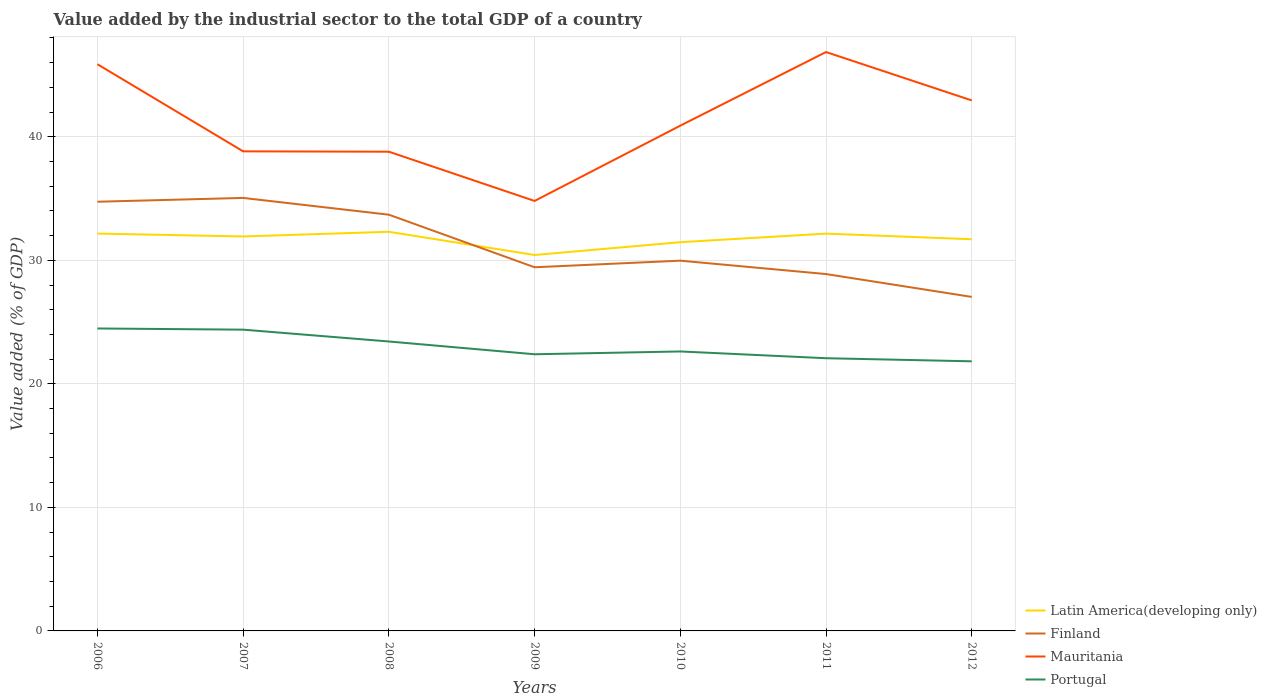Does the line corresponding to Mauritania intersect with the line corresponding to Portugal?
Keep it short and to the point. No. Is the number of lines equal to the number of legend labels?
Keep it short and to the point. Yes. Across all years, what is the maximum value added by the industrial sector to the total GDP in Latin America(developing only)?
Provide a succinct answer. 30.43. In which year was the value added by the industrial sector to the total GDP in Portugal maximum?
Keep it short and to the point. 2012. What is the total value added by the industrial sector to the total GDP in Mauritania in the graph?
Your answer should be compact. -2.04. What is the difference between the highest and the second highest value added by the industrial sector to the total GDP in Latin America(developing only)?
Offer a terse response. 1.88. How many years are there in the graph?
Ensure brevity in your answer.  7. What is the difference between two consecutive major ticks on the Y-axis?
Provide a short and direct response. 10. Are the values on the major ticks of Y-axis written in scientific E-notation?
Offer a very short reply. No. Does the graph contain grids?
Make the answer very short. Yes. How are the legend labels stacked?
Provide a succinct answer. Vertical. What is the title of the graph?
Ensure brevity in your answer.  Value added by the industrial sector to the total GDP of a country. Does "Pacific island small states" appear as one of the legend labels in the graph?
Provide a succinct answer. No. What is the label or title of the X-axis?
Make the answer very short. Years. What is the label or title of the Y-axis?
Offer a terse response. Value added (% of GDP). What is the Value added (% of GDP) in Latin America(developing only) in 2006?
Give a very brief answer. 32.17. What is the Value added (% of GDP) of Finland in 2006?
Keep it short and to the point. 34.74. What is the Value added (% of GDP) in Mauritania in 2006?
Your answer should be compact. 45.88. What is the Value added (% of GDP) of Portugal in 2006?
Keep it short and to the point. 24.49. What is the Value added (% of GDP) of Latin America(developing only) in 2007?
Offer a very short reply. 31.93. What is the Value added (% of GDP) in Finland in 2007?
Your response must be concise. 35.05. What is the Value added (% of GDP) of Mauritania in 2007?
Provide a succinct answer. 38.82. What is the Value added (% of GDP) in Portugal in 2007?
Your answer should be compact. 24.39. What is the Value added (% of GDP) of Latin America(developing only) in 2008?
Ensure brevity in your answer.  32.31. What is the Value added (% of GDP) of Finland in 2008?
Offer a terse response. 33.7. What is the Value added (% of GDP) of Mauritania in 2008?
Give a very brief answer. 38.8. What is the Value added (% of GDP) in Portugal in 2008?
Give a very brief answer. 23.43. What is the Value added (% of GDP) in Latin America(developing only) in 2009?
Your answer should be very brief. 30.43. What is the Value added (% of GDP) in Finland in 2009?
Provide a short and direct response. 29.44. What is the Value added (% of GDP) of Mauritania in 2009?
Your answer should be compact. 34.81. What is the Value added (% of GDP) in Portugal in 2009?
Make the answer very short. 22.4. What is the Value added (% of GDP) of Latin America(developing only) in 2010?
Your answer should be very brief. 31.47. What is the Value added (% of GDP) in Finland in 2010?
Give a very brief answer. 29.97. What is the Value added (% of GDP) of Mauritania in 2010?
Your response must be concise. 40.9. What is the Value added (% of GDP) in Portugal in 2010?
Provide a succinct answer. 22.62. What is the Value added (% of GDP) of Latin America(developing only) in 2011?
Provide a succinct answer. 32.16. What is the Value added (% of GDP) of Finland in 2011?
Make the answer very short. 28.89. What is the Value added (% of GDP) of Mauritania in 2011?
Provide a short and direct response. 46.86. What is the Value added (% of GDP) in Portugal in 2011?
Ensure brevity in your answer.  22.08. What is the Value added (% of GDP) of Latin America(developing only) in 2012?
Provide a succinct answer. 31.71. What is the Value added (% of GDP) of Finland in 2012?
Make the answer very short. 27.04. What is the Value added (% of GDP) in Mauritania in 2012?
Keep it short and to the point. 42.95. What is the Value added (% of GDP) of Portugal in 2012?
Your response must be concise. 21.83. Across all years, what is the maximum Value added (% of GDP) in Latin America(developing only)?
Your response must be concise. 32.31. Across all years, what is the maximum Value added (% of GDP) of Finland?
Provide a short and direct response. 35.05. Across all years, what is the maximum Value added (% of GDP) in Mauritania?
Make the answer very short. 46.86. Across all years, what is the maximum Value added (% of GDP) in Portugal?
Offer a very short reply. 24.49. Across all years, what is the minimum Value added (% of GDP) of Latin America(developing only)?
Keep it short and to the point. 30.43. Across all years, what is the minimum Value added (% of GDP) in Finland?
Your answer should be compact. 27.04. Across all years, what is the minimum Value added (% of GDP) of Mauritania?
Ensure brevity in your answer.  34.81. Across all years, what is the minimum Value added (% of GDP) in Portugal?
Give a very brief answer. 21.83. What is the total Value added (% of GDP) of Latin America(developing only) in the graph?
Ensure brevity in your answer.  222.19. What is the total Value added (% of GDP) in Finland in the graph?
Provide a succinct answer. 218.84. What is the total Value added (% of GDP) of Mauritania in the graph?
Provide a short and direct response. 289.02. What is the total Value added (% of GDP) in Portugal in the graph?
Offer a very short reply. 161.23. What is the difference between the Value added (% of GDP) in Latin America(developing only) in 2006 and that in 2007?
Your answer should be compact. 0.23. What is the difference between the Value added (% of GDP) in Finland in 2006 and that in 2007?
Offer a terse response. -0.31. What is the difference between the Value added (% of GDP) of Mauritania in 2006 and that in 2007?
Offer a terse response. 7.05. What is the difference between the Value added (% of GDP) in Portugal in 2006 and that in 2007?
Make the answer very short. 0.1. What is the difference between the Value added (% of GDP) in Latin America(developing only) in 2006 and that in 2008?
Keep it short and to the point. -0.14. What is the difference between the Value added (% of GDP) in Finland in 2006 and that in 2008?
Offer a very short reply. 1.05. What is the difference between the Value added (% of GDP) in Mauritania in 2006 and that in 2008?
Offer a terse response. 7.08. What is the difference between the Value added (% of GDP) of Portugal in 2006 and that in 2008?
Provide a short and direct response. 1.05. What is the difference between the Value added (% of GDP) of Latin America(developing only) in 2006 and that in 2009?
Offer a terse response. 1.74. What is the difference between the Value added (% of GDP) in Finland in 2006 and that in 2009?
Provide a short and direct response. 5.31. What is the difference between the Value added (% of GDP) in Mauritania in 2006 and that in 2009?
Offer a terse response. 11.07. What is the difference between the Value added (% of GDP) of Portugal in 2006 and that in 2009?
Your response must be concise. 2.09. What is the difference between the Value added (% of GDP) of Latin America(developing only) in 2006 and that in 2010?
Give a very brief answer. 0.7. What is the difference between the Value added (% of GDP) of Finland in 2006 and that in 2010?
Provide a short and direct response. 4.77. What is the difference between the Value added (% of GDP) in Mauritania in 2006 and that in 2010?
Ensure brevity in your answer.  4.97. What is the difference between the Value added (% of GDP) of Portugal in 2006 and that in 2010?
Offer a terse response. 1.86. What is the difference between the Value added (% of GDP) of Latin America(developing only) in 2006 and that in 2011?
Your answer should be very brief. 0.01. What is the difference between the Value added (% of GDP) in Finland in 2006 and that in 2011?
Your answer should be very brief. 5.85. What is the difference between the Value added (% of GDP) in Mauritania in 2006 and that in 2011?
Offer a very short reply. -0.99. What is the difference between the Value added (% of GDP) in Portugal in 2006 and that in 2011?
Keep it short and to the point. 2.41. What is the difference between the Value added (% of GDP) of Latin America(developing only) in 2006 and that in 2012?
Your answer should be very brief. 0.46. What is the difference between the Value added (% of GDP) in Finland in 2006 and that in 2012?
Offer a very short reply. 7.7. What is the difference between the Value added (% of GDP) of Mauritania in 2006 and that in 2012?
Ensure brevity in your answer.  2.93. What is the difference between the Value added (% of GDP) in Portugal in 2006 and that in 2012?
Your answer should be compact. 2.66. What is the difference between the Value added (% of GDP) in Latin America(developing only) in 2007 and that in 2008?
Your answer should be very brief. -0.38. What is the difference between the Value added (% of GDP) in Finland in 2007 and that in 2008?
Offer a very short reply. 1.36. What is the difference between the Value added (% of GDP) in Mauritania in 2007 and that in 2008?
Keep it short and to the point. 0.03. What is the difference between the Value added (% of GDP) of Portugal in 2007 and that in 2008?
Offer a very short reply. 0.96. What is the difference between the Value added (% of GDP) in Latin America(developing only) in 2007 and that in 2009?
Your answer should be compact. 1.5. What is the difference between the Value added (% of GDP) of Finland in 2007 and that in 2009?
Your answer should be very brief. 5.61. What is the difference between the Value added (% of GDP) of Mauritania in 2007 and that in 2009?
Ensure brevity in your answer.  4.02. What is the difference between the Value added (% of GDP) in Portugal in 2007 and that in 2009?
Your answer should be very brief. 1.99. What is the difference between the Value added (% of GDP) of Latin America(developing only) in 2007 and that in 2010?
Make the answer very short. 0.46. What is the difference between the Value added (% of GDP) in Finland in 2007 and that in 2010?
Make the answer very short. 5.08. What is the difference between the Value added (% of GDP) in Mauritania in 2007 and that in 2010?
Give a very brief answer. -2.08. What is the difference between the Value added (% of GDP) of Portugal in 2007 and that in 2010?
Keep it short and to the point. 1.76. What is the difference between the Value added (% of GDP) of Latin America(developing only) in 2007 and that in 2011?
Ensure brevity in your answer.  -0.23. What is the difference between the Value added (% of GDP) in Finland in 2007 and that in 2011?
Your response must be concise. 6.16. What is the difference between the Value added (% of GDP) of Mauritania in 2007 and that in 2011?
Make the answer very short. -8.04. What is the difference between the Value added (% of GDP) in Portugal in 2007 and that in 2011?
Your response must be concise. 2.31. What is the difference between the Value added (% of GDP) of Latin America(developing only) in 2007 and that in 2012?
Your response must be concise. 0.23. What is the difference between the Value added (% of GDP) in Finland in 2007 and that in 2012?
Provide a short and direct response. 8.01. What is the difference between the Value added (% of GDP) in Mauritania in 2007 and that in 2012?
Offer a very short reply. -4.12. What is the difference between the Value added (% of GDP) in Portugal in 2007 and that in 2012?
Ensure brevity in your answer.  2.56. What is the difference between the Value added (% of GDP) of Latin America(developing only) in 2008 and that in 2009?
Your answer should be very brief. 1.88. What is the difference between the Value added (% of GDP) of Finland in 2008 and that in 2009?
Provide a succinct answer. 4.26. What is the difference between the Value added (% of GDP) in Mauritania in 2008 and that in 2009?
Provide a succinct answer. 3.99. What is the difference between the Value added (% of GDP) of Portugal in 2008 and that in 2009?
Provide a short and direct response. 1.03. What is the difference between the Value added (% of GDP) in Latin America(developing only) in 2008 and that in 2010?
Your response must be concise. 0.84. What is the difference between the Value added (% of GDP) in Finland in 2008 and that in 2010?
Offer a terse response. 3.72. What is the difference between the Value added (% of GDP) of Mauritania in 2008 and that in 2010?
Provide a short and direct response. -2.11. What is the difference between the Value added (% of GDP) of Portugal in 2008 and that in 2010?
Make the answer very short. 0.81. What is the difference between the Value added (% of GDP) in Latin America(developing only) in 2008 and that in 2011?
Ensure brevity in your answer.  0.15. What is the difference between the Value added (% of GDP) of Finland in 2008 and that in 2011?
Provide a succinct answer. 4.81. What is the difference between the Value added (% of GDP) in Mauritania in 2008 and that in 2011?
Your answer should be very brief. -8.07. What is the difference between the Value added (% of GDP) in Portugal in 2008 and that in 2011?
Your answer should be very brief. 1.35. What is the difference between the Value added (% of GDP) in Latin America(developing only) in 2008 and that in 2012?
Your response must be concise. 0.61. What is the difference between the Value added (% of GDP) of Finland in 2008 and that in 2012?
Ensure brevity in your answer.  6.66. What is the difference between the Value added (% of GDP) in Mauritania in 2008 and that in 2012?
Provide a succinct answer. -4.15. What is the difference between the Value added (% of GDP) of Portugal in 2008 and that in 2012?
Your answer should be compact. 1.61. What is the difference between the Value added (% of GDP) in Latin America(developing only) in 2009 and that in 2010?
Give a very brief answer. -1.04. What is the difference between the Value added (% of GDP) of Finland in 2009 and that in 2010?
Give a very brief answer. -0.53. What is the difference between the Value added (% of GDP) of Mauritania in 2009 and that in 2010?
Offer a very short reply. -6.1. What is the difference between the Value added (% of GDP) in Portugal in 2009 and that in 2010?
Ensure brevity in your answer.  -0.23. What is the difference between the Value added (% of GDP) of Latin America(developing only) in 2009 and that in 2011?
Your answer should be compact. -1.73. What is the difference between the Value added (% of GDP) of Finland in 2009 and that in 2011?
Provide a succinct answer. 0.55. What is the difference between the Value added (% of GDP) in Mauritania in 2009 and that in 2011?
Your answer should be very brief. -12.05. What is the difference between the Value added (% of GDP) of Portugal in 2009 and that in 2011?
Provide a short and direct response. 0.32. What is the difference between the Value added (% of GDP) in Latin America(developing only) in 2009 and that in 2012?
Offer a terse response. -1.27. What is the difference between the Value added (% of GDP) of Finland in 2009 and that in 2012?
Offer a terse response. 2.4. What is the difference between the Value added (% of GDP) of Mauritania in 2009 and that in 2012?
Give a very brief answer. -8.14. What is the difference between the Value added (% of GDP) in Portugal in 2009 and that in 2012?
Provide a succinct answer. 0.57. What is the difference between the Value added (% of GDP) of Latin America(developing only) in 2010 and that in 2011?
Your response must be concise. -0.69. What is the difference between the Value added (% of GDP) in Finland in 2010 and that in 2011?
Make the answer very short. 1.08. What is the difference between the Value added (% of GDP) in Mauritania in 2010 and that in 2011?
Provide a succinct answer. -5.96. What is the difference between the Value added (% of GDP) of Portugal in 2010 and that in 2011?
Your answer should be very brief. 0.55. What is the difference between the Value added (% of GDP) in Latin America(developing only) in 2010 and that in 2012?
Provide a short and direct response. -0.24. What is the difference between the Value added (% of GDP) in Finland in 2010 and that in 2012?
Make the answer very short. 2.93. What is the difference between the Value added (% of GDP) of Mauritania in 2010 and that in 2012?
Give a very brief answer. -2.04. What is the difference between the Value added (% of GDP) in Portugal in 2010 and that in 2012?
Your answer should be very brief. 0.8. What is the difference between the Value added (% of GDP) of Latin America(developing only) in 2011 and that in 2012?
Provide a short and direct response. 0.46. What is the difference between the Value added (% of GDP) of Finland in 2011 and that in 2012?
Ensure brevity in your answer.  1.85. What is the difference between the Value added (% of GDP) in Mauritania in 2011 and that in 2012?
Keep it short and to the point. 3.92. What is the difference between the Value added (% of GDP) in Portugal in 2011 and that in 2012?
Provide a succinct answer. 0.25. What is the difference between the Value added (% of GDP) of Latin America(developing only) in 2006 and the Value added (% of GDP) of Finland in 2007?
Give a very brief answer. -2.89. What is the difference between the Value added (% of GDP) in Latin America(developing only) in 2006 and the Value added (% of GDP) in Mauritania in 2007?
Offer a very short reply. -6.66. What is the difference between the Value added (% of GDP) in Latin America(developing only) in 2006 and the Value added (% of GDP) in Portugal in 2007?
Give a very brief answer. 7.78. What is the difference between the Value added (% of GDP) in Finland in 2006 and the Value added (% of GDP) in Mauritania in 2007?
Your response must be concise. -4.08. What is the difference between the Value added (% of GDP) in Finland in 2006 and the Value added (% of GDP) in Portugal in 2007?
Make the answer very short. 10.36. What is the difference between the Value added (% of GDP) of Mauritania in 2006 and the Value added (% of GDP) of Portugal in 2007?
Make the answer very short. 21.49. What is the difference between the Value added (% of GDP) of Latin America(developing only) in 2006 and the Value added (% of GDP) of Finland in 2008?
Provide a short and direct response. -1.53. What is the difference between the Value added (% of GDP) in Latin America(developing only) in 2006 and the Value added (% of GDP) in Mauritania in 2008?
Keep it short and to the point. -6.63. What is the difference between the Value added (% of GDP) in Latin America(developing only) in 2006 and the Value added (% of GDP) in Portugal in 2008?
Make the answer very short. 8.74. What is the difference between the Value added (% of GDP) of Finland in 2006 and the Value added (% of GDP) of Mauritania in 2008?
Your answer should be compact. -4.05. What is the difference between the Value added (% of GDP) in Finland in 2006 and the Value added (% of GDP) in Portugal in 2008?
Ensure brevity in your answer.  11.31. What is the difference between the Value added (% of GDP) of Mauritania in 2006 and the Value added (% of GDP) of Portugal in 2008?
Your answer should be compact. 22.45. What is the difference between the Value added (% of GDP) of Latin America(developing only) in 2006 and the Value added (% of GDP) of Finland in 2009?
Give a very brief answer. 2.73. What is the difference between the Value added (% of GDP) of Latin America(developing only) in 2006 and the Value added (% of GDP) of Mauritania in 2009?
Your response must be concise. -2.64. What is the difference between the Value added (% of GDP) of Latin America(developing only) in 2006 and the Value added (% of GDP) of Portugal in 2009?
Provide a short and direct response. 9.77. What is the difference between the Value added (% of GDP) of Finland in 2006 and the Value added (% of GDP) of Mauritania in 2009?
Provide a short and direct response. -0.06. What is the difference between the Value added (% of GDP) of Finland in 2006 and the Value added (% of GDP) of Portugal in 2009?
Your answer should be very brief. 12.35. What is the difference between the Value added (% of GDP) in Mauritania in 2006 and the Value added (% of GDP) in Portugal in 2009?
Keep it short and to the point. 23.48. What is the difference between the Value added (% of GDP) of Latin America(developing only) in 2006 and the Value added (% of GDP) of Finland in 2010?
Your response must be concise. 2.19. What is the difference between the Value added (% of GDP) of Latin America(developing only) in 2006 and the Value added (% of GDP) of Mauritania in 2010?
Keep it short and to the point. -8.74. What is the difference between the Value added (% of GDP) of Latin America(developing only) in 2006 and the Value added (% of GDP) of Portugal in 2010?
Offer a terse response. 9.54. What is the difference between the Value added (% of GDP) in Finland in 2006 and the Value added (% of GDP) in Mauritania in 2010?
Offer a very short reply. -6.16. What is the difference between the Value added (% of GDP) in Finland in 2006 and the Value added (% of GDP) in Portugal in 2010?
Ensure brevity in your answer.  12.12. What is the difference between the Value added (% of GDP) of Mauritania in 2006 and the Value added (% of GDP) of Portugal in 2010?
Your answer should be compact. 23.25. What is the difference between the Value added (% of GDP) of Latin America(developing only) in 2006 and the Value added (% of GDP) of Finland in 2011?
Your answer should be compact. 3.28. What is the difference between the Value added (% of GDP) in Latin America(developing only) in 2006 and the Value added (% of GDP) in Mauritania in 2011?
Your answer should be very brief. -14.7. What is the difference between the Value added (% of GDP) in Latin America(developing only) in 2006 and the Value added (% of GDP) in Portugal in 2011?
Make the answer very short. 10.09. What is the difference between the Value added (% of GDP) in Finland in 2006 and the Value added (% of GDP) in Mauritania in 2011?
Give a very brief answer. -12.12. What is the difference between the Value added (% of GDP) of Finland in 2006 and the Value added (% of GDP) of Portugal in 2011?
Keep it short and to the point. 12.67. What is the difference between the Value added (% of GDP) of Mauritania in 2006 and the Value added (% of GDP) of Portugal in 2011?
Ensure brevity in your answer.  23.8. What is the difference between the Value added (% of GDP) of Latin America(developing only) in 2006 and the Value added (% of GDP) of Finland in 2012?
Provide a succinct answer. 5.13. What is the difference between the Value added (% of GDP) in Latin America(developing only) in 2006 and the Value added (% of GDP) in Mauritania in 2012?
Provide a succinct answer. -10.78. What is the difference between the Value added (% of GDP) of Latin America(developing only) in 2006 and the Value added (% of GDP) of Portugal in 2012?
Offer a very short reply. 10.34. What is the difference between the Value added (% of GDP) of Finland in 2006 and the Value added (% of GDP) of Mauritania in 2012?
Provide a short and direct response. -8.2. What is the difference between the Value added (% of GDP) of Finland in 2006 and the Value added (% of GDP) of Portugal in 2012?
Make the answer very short. 12.92. What is the difference between the Value added (% of GDP) in Mauritania in 2006 and the Value added (% of GDP) in Portugal in 2012?
Offer a terse response. 24.05. What is the difference between the Value added (% of GDP) of Latin America(developing only) in 2007 and the Value added (% of GDP) of Finland in 2008?
Make the answer very short. -1.76. What is the difference between the Value added (% of GDP) in Latin America(developing only) in 2007 and the Value added (% of GDP) in Mauritania in 2008?
Your answer should be very brief. -6.86. What is the difference between the Value added (% of GDP) of Latin America(developing only) in 2007 and the Value added (% of GDP) of Portugal in 2008?
Give a very brief answer. 8.5. What is the difference between the Value added (% of GDP) in Finland in 2007 and the Value added (% of GDP) in Mauritania in 2008?
Your response must be concise. -3.74. What is the difference between the Value added (% of GDP) in Finland in 2007 and the Value added (% of GDP) in Portugal in 2008?
Make the answer very short. 11.62. What is the difference between the Value added (% of GDP) of Mauritania in 2007 and the Value added (% of GDP) of Portugal in 2008?
Your response must be concise. 15.39. What is the difference between the Value added (% of GDP) of Latin America(developing only) in 2007 and the Value added (% of GDP) of Finland in 2009?
Provide a succinct answer. 2.49. What is the difference between the Value added (% of GDP) in Latin America(developing only) in 2007 and the Value added (% of GDP) in Mauritania in 2009?
Your response must be concise. -2.87. What is the difference between the Value added (% of GDP) of Latin America(developing only) in 2007 and the Value added (% of GDP) of Portugal in 2009?
Offer a very short reply. 9.54. What is the difference between the Value added (% of GDP) of Finland in 2007 and the Value added (% of GDP) of Mauritania in 2009?
Give a very brief answer. 0.24. What is the difference between the Value added (% of GDP) in Finland in 2007 and the Value added (% of GDP) in Portugal in 2009?
Make the answer very short. 12.66. What is the difference between the Value added (% of GDP) in Mauritania in 2007 and the Value added (% of GDP) in Portugal in 2009?
Your answer should be compact. 16.43. What is the difference between the Value added (% of GDP) in Latin America(developing only) in 2007 and the Value added (% of GDP) in Finland in 2010?
Provide a succinct answer. 1.96. What is the difference between the Value added (% of GDP) in Latin America(developing only) in 2007 and the Value added (% of GDP) in Mauritania in 2010?
Your response must be concise. -8.97. What is the difference between the Value added (% of GDP) in Latin America(developing only) in 2007 and the Value added (% of GDP) in Portugal in 2010?
Ensure brevity in your answer.  9.31. What is the difference between the Value added (% of GDP) of Finland in 2007 and the Value added (% of GDP) of Mauritania in 2010?
Offer a terse response. -5.85. What is the difference between the Value added (% of GDP) of Finland in 2007 and the Value added (% of GDP) of Portugal in 2010?
Provide a short and direct response. 12.43. What is the difference between the Value added (% of GDP) of Mauritania in 2007 and the Value added (% of GDP) of Portugal in 2010?
Provide a succinct answer. 16.2. What is the difference between the Value added (% of GDP) of Latin America(developing only) in 2007 and the Value added (% of GDP) of Finland in 2011?
Make the answer very short. 3.04. What is the difference between the Value added (% of GDP) of Latin America(developing only) in 2007 and the Value added (% of GDP) of Mauritania in 2011?
Ensure brevity in your answer.  -14.93. What is the difference between the Value added (% of GDP) in Latin America(developing only) in 2007 and the Value added (% of GDP) in Portugal in 2011?
Keep it short and to the point. 9.86. What is the difference between the Value added (% of GDP) of Finland in 2007 and the Value added (% of GDP) of Mauritania in 2011?
Give a very brief answer. -11.81. What is the difference between the Value added (% of GDP) in Finland in 2007 and the Value added (% of GDP) in Portugal in 2011?
Offer a terse response. 12.98. What is the difference between the Value added (% of GDP) in Mauritania in 2007 and the Value added (% of GDP) in Portugal in 2011?
Your answer should be very brief. 16.75. What is the difference between the Value added (% of GDP) of Latin America(developing only) in 2007 and the Value added (% of GDP) of Finland in 2012?
Provide a succinct answer. 4.89. What is the difference between the Value added (% of GDP) in Latin America(developing only) in 2007 and the Value added (% of GDP) in Mauritania in 2012?
Offer a very short reply. -11.01. What is the difference between the Value added (% of GDP) in Latin America(developing only) in 2007 and the Value added (% of GDP) in Portugal in 2012?
Keep it short and to the point. 10.11. What is the difference between the Value added (% of GDP) of Finland in 2007 and the Value added (% of GDP) of Mauritania in 2012?
Offer a terse response. -7.89. What is the difference between the Value added (% of GDP) in Finland in 2007 and the Value added (% of GDP) in Portugal in 2012?
Keep it short and to the point. 13.23. What is the difference between the Value added (% of GDP) of Mauritania in 2007 and the Value added (% of GDP) of Portugal in 2012?
Your answer should be compact. 17. What is the difference between the Value added (% of GDP) of Latin America(developing only) in 2008 and the Value added (% of GDP) of Finland in 2009?
Keep it short and to the point. 2.87. What is the difference between the Value added (% of GDP) of Latin America(developing only) in 2008 and the Value added (% of GDP) of Mauritania in 2009?
Offer a terse response. -2.5. What is the difference between the Value added (% of GDP) of Latin America(developing only) in 2008 and the Value added (% of GDP) of Portugal in 2009?
Your answer should be compact. 9.92. What is the difference between the Value added (% of GDP) in Finland in 2008 and the Value added (% of GDP) in Mauritania in 2009?
Give a very brief answer. -1.11. What is the difference between the Value added (% of GDP) of Finland in 2008 and the Value added (% of GDP) of Portugal in 2009?
Your answer should be very brief. 11.3. What is the difference between the Value added (% of GDP) in Mauritania in 2008 and the Value added (% of GDP) in Portugal in 2009?
Your answer should be very brief. 16.4. What is the difference between the Value added (% of GDP) of Latin America(developing only) in 2008 and the Value added (% of GDP) of Finland in 2010?
Your answer should be very brief. 2.34. What is the difference between the Value added (% of GDP) of Latin America(developing only) in 2008 and the Value added (% of GDP) of Mauritania in 2010?
Make the answer very short. -8.59. What is the difference between the Value added (% of GDP) in Latin America(developing only) in 2008 and the Value added (% of GDP) in Portugal in 2010?
Offer a very short reply. 9.69. What is the difference between the Value added (% of GDP) of Finland in 2008 and the Value added (% of GDP) of Mauritania in 2010?
Make the answer very short. -7.21. What is the difference between the Value added (% of GDP) of Finland in 2008 and the Value added (% of GDP) of Portugal in 2010?
Keep it short and to the point. 11.07. What is the difference between the Value added (% of GDP) of Mauritania in 2008 and the Value added (% of GDP) of Portugal in 2010?
Give a very brief answer. 16.17. What is the difference between the Value added (% of GDP) of Latin America(developing only) in 2008 and the Value added (% of GDP) of Finland in 2011?
Provide a succinct answer. 3.42. What is the difference between the Value added (% of GDP) in Latin America(developing only) in 2008 and the Value added (% of GDP) in Mauritania in 2011?
Ensure brevity in your answer.  -14.55. What is the difference between the Value added (% of GDP) in Latin America(developing only) in 2008 and the Value added (% of GDP) in Portugal in 2011?
Offer a terse response. 10.24. What is the difference between the Value added (% of GDP) in Finland in 2008 and the Value added (% of GDP) in Mauritania in 2011?
Provide a succinct answer. -13.17. What is the difference between the Value added (% of GDP) in Finland in 2008 and the Value added (% of GDP) in Portugal in 2011?
Your response must be concise. 11.62. What is the difference between the Value added (% of GDP) in Mauritania in 2008 and the Value added (% of GDP) in Portugal in 2011?
Offer a terse response. 16.72. What is the difference between the Value added (% of GDP) in Latin America(developing only) in 2008 and the Value added (% of GDP) in Finland in 2012?
Your response must be concise. 5.27. What is the difference between the Value added (% of GDP) in Latin America(developing only) in 2008 and the Value added (% of GDP) in Mauritania in 2012?
Keep it short and to the point. -10.64. What is the difference between the Value added (% of GDP) in Latin America(developing only) in 2008 and the Value added (% of GDP) in Portugal in 2012?
Give a very brief answer. 10.49. What is the difference between the Value added (% of GDP) in Finland in 2008 and the Value added (% of GDP) in Mauritania in 2012?
Give a very brief answer. -9.25. What is the difference between the Value added (% of GDP) of Finland in 2008 and the Value added (% of GDP) of Portugal in 2012?
Your response must be concise. 11.87. What is the difference between the Value added (% of GDP) in Mauritania in 2008 and the Value added (% of GDP) in Portugal in 2012?
Make the answer very short. 16.97. What is the difference between the Value added (% of GDP) of Latin America(developing only) in 2009 and the Value added (% of GDP) of Finland in 2010?
Provide a succinct answer. 0.46. What is the difference between the Value added (% of GDP) in Latin America(developing only) in 2009 and the Value added (% of GDP) in Mauritania in 2010?
Your response must be concise. -10.47. What is the difference between the Value added (% of GDP) of Latin America(developing only) in 2009 and the Value added (% of GDP) of Portugal in 2010?
Keep it short and to the point. 7.81. What is the difference between the Value added (% of GDP) in Finland in 2009 and the Value added (% of GDP) in Mauritania in 2010?
Provide a short and direct response. -11.46. What is the difference between the Value added (% of GDP) of Finland in 2009 and the Value added (% of GDP) of Portugal in 2010?
Make the answer very short. 6.82. What is the difference between the Value added (% of GDP) in Mauritania in 2009 and the Value added (% of GDP) in Portugal in 2010?
Keep it short and to the point. 12.18. What is the difference between the Value added (% of GDP) in Latin America(developing only) in 2009 and the Value added (% of GDP) in Finland in 2011?
Offer a very short reply. 1.54. What is the difference between the Value added (% of GDP) of Latin America(developing only) in 2009 and the Value added (% of GDP) of Mauritania in 2011?
Provide a short and direct response. -16.43. What is the difference between the Value added (% of GDP) of Latin America(developing only) in 2009 and the Value added (% of GDP) of Portugal in 2011?
Provide a succinct answer. 8.36. What is the difference between the Value added (% of GDP) in Finland in 2009 and the Value added (% of GDP) in Mauritania in 2011?
Offer a very short reply. -17.42. What is the difference between the Value added (% of GDP) of Finland in 2009 and the Value added (% of GDP) of Portugal in 2011?
Your answer should be compact. 7.36. What is the difference between the Value added (% of GDP) of Mauritania in 2009 and the Value added (% of GDP) of Portugal in 2011?
Your answer should be compact. 12.73. What is the difference between the Value added (% of GDP) of Latin America(developing only) in 2009 and the Value added (% of GDP) of Finland in 2012?
Provide a succinct answer. 3.39. What is the difference between the Value added (% of GDP) of Latin America(developing only) in 2009 and the Value added (% of GDP) of Mauritania in 2012?
Provide a short and direct response. -12.52. What is the difference between the Value added (% of GDP) of Latin America(developing only) in 2009 and the Value added (% of GDP) of Portugal in 2012?
Keep it short and to the point. 8.61. What is the difference between the Value added (% of GDP) in Finland in 2009 and the Value added (% of GDP) in Mauritania in 2012?
Make the answer very short. -13.51. What is the difference between the Value added (% of GDP) in Finland in 2009 and the Value added (% of GDP) in Portugal in 2012?
Your answer should be very brief. 7.61. What is the difference between the Value added (% of GDP) in Mauritania in 2009 and the Value added (% of GDP) in Portugal in 2012?
Provide a short and direct response. 12.98. What is the difference between the Value added (% of GDP) of Latin America(developing only) in 2010 and the Value added (% of GDP) of Finland in 2011?
Your answer should be compact. 2.58. What is the difference between the Value added (% of GDP) in Latin America(developing only) in 2010 and the Value added (% of GDP) in Mauritania in 2011?
Your answer should be compact. -15.39. What is the difference between the Value added (% of GDP) of Latin America(developing only) in 2010 and the Value added (% of GDP) of Portugal in 2011?
Provide a succinct answer. 9.39. What is the difference between the Value added (% of GDP) in Finland in 2010 and the Value added (% of GDP) in Mauritania in 2011?
Your answer should be compact. -16.89. What is the difference between the Value added (% of GDP) of Finland in 2010 and the Value added (% of GDP) of Portugal in 2011?
Make the answer very short. 7.9. What is the difference between the Value added (% of GDP) of Mauritania in 2010 and the Value added (% of GDP) of Portugal in 2011?
Your answer should be very brief. 18.83. What is the difference between the Value added (% of GDP) of Latin America(developing only) in 2010 and the Value added (% of GDP) of Finland in 2012?
Ensure brevity in your answer.  4.43. What is the difference between the Value added (% of GDP) in Latin America(developing only) in 2010 and the Value added (% of GDP) in Mauritania in 2012?
Your response must be concise. -11.48. What is the difference between the Value added (% of GDP) in Latin America(developing only) in 2010 and the Value added (% of GDP) in Portugal in 2012?
Offer a very short reply. 9.64. What is the difference between the Value added (% of GDP) in Finland in 2010 and the Value added (% of GDP) in Mauritania in 2012?
Your answer should be compact. -12.97. What is the difference between the Value added (% of GDP) in Finland in 2010 and the Value added (% of GDP) in Portugal in 2012?
Keep it short and to the point. 8.15. What is the difference between the Value added (% of GDP) in Mauritania in 2010 and the Value added (% of GDP) in Portugal in 2012?
Provide a short and direct response. 19.08. What is the difference between the Value added (% of GDP) of Latin America(developing only) in 2011 and the Value added (% of GDP) of Finland in 2012?
Give a very brief answer. 5.12. What is the difference between the Value added (% of GDP) in Latin America(developing only) in 2011 and the Value added (% of GDP) in Mauritania in 2012?
Keep it short and to the point. -10.78. What is the difference between the Value added (% of GDP) in Latin America(developing only) in 2011 and the Value added (% of GDP) in Portugal in 2012?
Offer a very short reply. 10.34. What is the difference between the Value added (% of GDP) of Finland in 2011 and the Value added (% of GDP) of Mauritania in 2012?
Offer a very short reply. -14.06. What is the difference between the Value added (% of GDP) in Finland in 2011 and the Value added (% of GDP) in Portugal in 2012?
Provide a succinct answer. 7.06. What is the difference between the Value added (% of GDP) in Mauritania in 2011 and the Value added (% of GDP) in Portugal in 2012?
Keep it short and to the point. 25.04. What is the average Value added (% of GDP) of Latin America(developing only) per year?
Your response must be concise. 31.74. What is the average Value added (% of GDP) of Finland per year?
Your response must be concise. 31.26. What is the average Value added (% of GDP) in Mauritania per year?
Your response must be concise. 41.29. What is the average Value added (% of GDP) of Portugal per year?
Provide a short and direct response. 23.03. In the year 2006, what is the difference between the Value added (% of GDP) of Latin America(developing only) and Value added (% of GDP) of Finland?
Your answer should be very brief. -2.58. In the year 2006, what is the difference between the Value added (% of GDP) of Latin America(developing only) and Value added (% of GDP) of Mauritania?
Provide a short and direct response. -13.71. In the year 2006, what is the difference between the Value added (% of GDP) in Latin America(developing only) and Value added (% of GDP) in Portugal?
Make the answer very short. 7.68. In the year 2006, what is the difference between the Value added (% of GDP) of Finland and Value added (% of GDP) of Mauritania?
Your answer should be compact. -11.13. In the year 2006, what is the difference between the Value added (% of GDP) of Finland and Value added (% of GDP) of Portugal?
Offer a very short reply. 10.26. In the year 2006, what is the difference between the Value added (% of GDP) of Mauritania and Value added (% of GDP) of Portugal?
Keep it short and to the point. 21.39. In the year 2007, what is the difference between the Value added (% of GDP) in Latin America(developing only) and Value added (% of GDP) in Finland?
Ensure brevity in your answer.  -3.12. In the year 2007, what is the difference between the Value added (% of GDP) of Latin America(developing only) and Value added (% of GDP) of Mauritania?
Provide a short and direct response. -6.89. In the year 2007, what is the difference between the Value added (% of GDP) of Latin America(developing only) and Value added (% of GDP) of Portugal?
Provide a succinct answer. 7.54. In the year 2007, what is the difference between the Value added (% of GDP) of Finland and Value added (% of GDP) of Mauritania?
Keep it short and to the point. -3.77. In the year 2007, what is the difference between the Value added (% of GDP) of Finland and Value added (% of GDP) of Portugal?
Offer a very short reply. 10.66. In the year 2007, what is the difference between the Value added (% of GDP) in Mauritania and Value added (% of GDP) in Portugal?
Ensure brevity in your answer.  14.44. In the year 2008, what is the difference between the Value added (% of GDP) in Latin America(developing only) and Value added (% of GDP) in Finland?
Your answer should be very brief. -1.38. In the year 2008, what is the difference between the Value added (% of GDP) in Latin America(developing only) and Value added (% of GDP) in Mauritania?
Your answer should be compact. -6.48. In the year 2008, what is the difference between the Value added (% of GDP) of Latin America(developing only) and Value added (% of GDP) of Portugal?
Provide a short and direct response. 8.88. In the year 2008, what is the difference between the Value added (% of GDP) of Finland and Value added (% of GDP) of Mauritania?
Give a very brief answer. -5.1. In the year 2008, what is the difference between the Value added (% of GDP) of Finland and Value added (% of GDP) of Portugal?
Your answer should be compact. 10.26. In the year 2008, what is the difference between the Value added (% of GDP) of Mauritania and Value added (% of GDP) of Portugal?
Offer a very short reply. 15.36. In the year 2009, what is the difference between the Value added (% of GDP) of Latin America(developing only) and Value added (% of GDP) of Finland?
Your response must be concise. 0.99. In the year 2009, what is the difference between the Value added (% of GDP) in Latin America(developing only) and Value added (% of GDP) in Mauritania?
Your answer should be compact. -4.38. In the year 2009, what is the difference between the Value added (% of GDP) in Latin America(developing only) and Value added (% of GDP) in Portugal?
Ensure brevity in your answer.  8.04. In the year 2009, what is the difference between the Value added (% of GDP) in Finland and Value added (% of GDP) in Mauritania?
Provide a short and direct response. -5.37. In the year 2009, what is the difference between the Value added (% of GDP) in Finland and Value added (% of GDP) in Portugal?
Your answer should be very brief. 7.04. In the year 2009, what is the difference between the Value added (% of GDP) of Mauritania and Value added (% of GDP) of Portugal?
Keep it short and to the point. 12.41. In the year 2010, what is the difference between the Value added (% of GDP) of Latin America(developing only) and Value added (% of GDP) of Finland?
Give a very brief answer. 1.5. In the year 2010, what is the difference between the Value added (% of GDP) in Latin America(developing only) and Value added (% of GDP) in Mauritania?
Your response must be concise. -9.43. In the year 2010, what is the difference between the Value added (% of GDP) of Latin America(developing only) and Value added (% of GDP) of Portugal?
Keep it short and to the point. 8.85. In the year 2010, what is the difference between the Value added (% of GDP) of Finland and Value added (% of GDP) of Mauritania?
Offer a terse response. -10.93. In the year 2010, what is the difference between the Value added (% of GDP) in Finland and Value added (% of GDP) in Portugal?
Offer a very short reply. 7.35. In the year 2010, what is the difference between the Value added (% of GDP) in Mauritania and Value added (% of GDP) in Portugal?
Provide a succinct answer. 18.28. In the year 2011, what is the difference between the Value added (% of GDP) in Latin America(developing only) and Value added (% of GDP) in Finland?
Your answer should be compact. 3.27. In the year 2011, what is the difference between the Value added (% of GDP) of Latin America(developing only) and Value added (% of GDP) of Mauritania?
Ensure brevity in your answer.  -14.7. In the year 2011, what is the difference between the Value added (% of GDP) of Latin America(developing only) and Value added (% of GDP) of Portugal?
Ensure brevity in your answer.  10.09. In the year 2011, what is the difference between the Value added (% of GDP) in Finland and Value added (% of GDP) in Mauritania?
Your answer should be compact. -17.97. In the year 2011, what is the difference between the Value added (% of GDP) of Finland and Value added (% of GDP) of Portugal?
Ensure brevity in your answer.  6.81. In the year 2011, what is the difference between the Value added (% of GDP) in Mauritania and Value added (% of GDP) in Portugal?
Your response must be concise. 24.79. In the year 2012, what is the difference between the Value added (% of GDP) in Latin America(developing only) and Value added (% of GDP) in Finland?
Offer a very short reply. 4.67. In the year 2012, what is the difference between the Value added (% of GDP) of Latin America(developing only) and Value added (% of GDP) of Mauritania?
Provide a succinct answer. -11.24. In the year 2012, what is the difference between the Value added (% of GDP) of Latin America(developing only) and Value added (% of GDP) of Portugal?
Offer a very short reply. 9.88. In the year 2012, what is the difference between the Value added (% of GDP) in Finland and Value added (% of GDP) in Mauritania?
Your response must be concise. -15.91. In the year 2012, what is the difference between the Value added (% of GDP) in Finland and Value added (% of GDP) in Portugal?
Give a very brief answer. 5.21. In the year 2012, what is the difference between the Value added (% of GDP) of Mauritania and Value added (% of GDP) of Portugal?
Give a very brief answer. 21.12. What is the ratio of the Value added (% of GDP) of Latin America(developing only) in 2006 to that in 2007?
Offer a very short reply. 1.01. What is the ratio of the Value added (% of GDP) in Finland in 2006 to that in 2007?
Provide a succinct answer. 0.99. What is the ratio of the Value added (% of GDP) of Mauritania in 2006 to that in 2007?
Ensure brevity in your answer.  1.18. What is the ratio of the Value added (% of GDP) in Finland in 2006 to that in 2008?
Offer a very short reply. 1.03. What is the ratio of the Value added (% of GDP) in Mauritania in 2006 to that in 2008?
Your answer should be very brief. 1.18. What is the ratio of the Value added (% of GDP) in Portugal in 2006 to that in 2008?
Make the answer very short. 1.04. What is the ratio of the Value added (% of GDP) of Latin America(developing only) in 2006 to that in 2009?
Give a very brief answer. 1.06. What is the ratio of the Value added (% of GDP) of Finland in 2006 to that in 2009?
Provide a succinct answer. 1.18. What is the ratio of the Value added (% of GDP) of Mauritania in 2006 to that in 2009?
Provide a short and direct response. 1.32. What is the ratio of the Value added (% of GDP) of Portugal in 2006 to that in 2009?
Make the answer very short. 1.09. What is the ratio of the Value added (% of GDP) of Latin America(developing only) in 2006 to that in 2010?
Provide a short and direct response. 1.02. What is the ratio of the Value added (% of GDP) of Finland in 2006 to that in 2010?
Your response must be concise. 1.16. What is the ratio of the Value added (% of GDP) in Mauritania in 2006 to that in 2010?
Offer a very short reply. 1.12. What is the ratio of the Value added (% of GDP) in Portugal in 2006 to that in 2010?
Provide a short and direct response. 1.08. What is the ratio of the Value added (% of GDP) of Latin America(developing only) in 2006 to that in 2011?
Offer a terse response. 1. What is the ratio of the Value added (% of GDP) in Finland in 2006 to that in 2011?
Offer a very short reply. 1.2. What is the ratio of the Value added (% of GDP) of Mauritania in 2006 to that in 2011?
Ensure brevity in your answer.  0.98. What is the ratio of the Value added (% of GDP) in Portugal in 2006 to that in 2011?
Offer a terse response. 1.11. What is the ratio of the Value added (% of GDP) in Latin America(developing only) in 2006 to that in 2012?
Your response must be concise. 1.01. What is the ratio of the Value added (% of GDP) in Finland in 2006 to that in 2012?
Provide a short and direct response. 1.28. What is the ratio of the Value added (% of GDP) in Mauritania in 2006 to that in 2012?
Offer a terse response. 1.07. What is the ratio of the Value added (% of GDP) of Portugal in 2006 to that in 2012?
Your answer should be very brief. 1.12. What is the ratio of the Value added (% of GDP) in Latin America(developing only) in 2007 to that in 2008?
Offer a very short reply. 0.99. What is the ratio of the Value added (% of GDP) in Finland in 2007 to that in 2008?
Ensure brevity in your answer.  1.04. What is the ratio of the Value added (% of GDP) in Portugal in 2007 to that in 2008?
Make the answer very short. 1.04. What is the ratio of the Value added (% of GDP) in Latin America(developing only) in 2007 to that in 2009?
Offer a terse response. 1.05. What is the ratio of the Value added (% of GDP) in Finland in 2007 to that in 2009?
Provide a short and direct response. 1.19. What is the ratio of the Value added (% of GDP) of Mauritania in 2007 to that in 2009?
Provide a short and direct response. 1.12. What is the ratio of the Value added (% of GDP) in Portugal in 2007 to that in 2009?
Offer a very short reply. 1.09. What is the ratio of the Value added (% of GDP) in Latin America(developing only) in 2007 to that in 2010?
Provide a succinct answer. 1.01. What is the ratio of the Value added (% of GDP) in Finland in 2007 to that in 2010?
Provide a short and direct response. 1.17. What is the ratio of the Value added (% of GDP) in Mauritania in 2007 to that in 2010?
Make the answer very short. 0.95. What is the ratio of the Value added (% of GDP) of Portugal in 2007 to that in 2010?
Keep it short and to the point. 1.08. What is the ratio of the Value added (% of GDP) of Finland in 2007 to that in 2011?
Offer a very short reply. 1.21. What is the ratio of the Value added (% of GDP) in Mauritania in 2007 to that in 2011?
Your answer should be compact. 0.83. What is the ratio of the Value added (% of GDP) of Portugal in 2007 to that in 2011?
Keep it short and to the point. 1.1. What is the ratio of the Value added (% of GDP) in Latin America(developing only) in 2007 to that in 2012?
Your response must be concise. 1.01. What is the ratio of the Value added (% of GDP) of Finland in 2007 to that in 2012?
Ensure brevity in your answer.  1.3. What is the ratio of the Value added (% of GDP) in Mauritania in 2007 to that in 2012?
Provide a succinct answer. 0.9. What is the ratio of the Value added (% of GDP) in Portugal in 2007 to that in 2012?
Keep it short and to the point. 1.12. What is the ratio of the Value added (% of GDP) of Latin America(developing only) in 2008 to that in 2009?
Your answer should be very brief. 1.06. What is the ratio of the Value added (% of GDP) in Finland in 2008 to that in 2009?
Offer a terse response. 1.14. What is the ratio of the Value added (% of GDP) in Mauritania in 2008 to that in 2009?
Offer a terse response. 1.11. What is the ratio of the Value added (% of GDP) in Portugal in 2008 to that in 2009?
Provide a succinct answer. 1.05. What is the ratio of the Value added (% of GDP) of Latin America(developing only) in 2008 to that in 2010?
Your answer should be very brief. 1.03. What is the ratio of the Value added (% of GDP) of Finland in 2008 to that in 2010?
Offer a terse response. 1.12. What is the ratio of the Value added (% of GDP) in Mauritania in 2008 to that in 2010?
Provide a short and direct response. 0.95. What is the ratio of the Value added (% of GDP) of Portugal in 2008 to that in 2010?
Your answer should be very brief. 1.04. What is the ratio of the Value added (% of GDP) in Finland in 2008 to that in 2011?
Your answer should be compact. 1.17. What is the ratio of the Value added (% of GDP) in Mauritania in 2008 to that in 2011?
Offer a very short reply. 0.83. What is the ratio of the Value added (% of GDP) of Portugal in 2008 to that in 2011?
Give a very brief answer. 1.06. What is the ratio of the Value added (% of GDP) in Latin America(developing only) in 2008 to that in 2012?
Your response must be concise. 1.02. What is the ratio of the Value added (% of GDP) in Finland in 2008 to that in 2012?
Offer a very short reply. 1.25. What is the ratio of the Value added (% of GDP) of Mauritania in 2008 to that in 2012?
Your answer should be very brief. 0.9. What is the ratio of the Value added (% of GDP) in Portugal in 2008 to that in 2012?
Offer a very short reply. 1.07. What is the ratio of the Value added (% of GDP) in Finland in 2009 to that in 2010?
Your answer should be compact. 0.98. What is the ratio of the Value added (% of GDP) of Mauritania in 2009 to that in 2010?
Provide a succinct answer. 0.85. What is the ratio of the Value added (% of GDP) of Portugal in 2009 to that in 2010?
Make the answer very short. 0.99. What is the ratio of the Value added (% of GDP) in Latin America(developing only) in 2009 to that in 2011?
Give a very brief answer. 0.95. What is the ratio of the Value added (% of GDP) of Mauritania in 2009 to that in 2011?
Keep it short and to the point. 0.74. What is the ratio of the Value added (% of GDP) in Portugal in 2009 to that in 2011?
Give a very brief answer. 1.01. What is the ratio of the Value added (% of GDP) in Latin America(developing only) in 2009 to that in 2012?
Give a very brief answer. 0.96. What is the ratio of the Value added (% of GDP) in Finland in 2009 to that in 2012?
Offer a very short reply. 1.09. What is the ratio of the Value added (% of GDP) in Mauritania in 2009 to that in 2012?
Make the answer very short. 0.81. What is the ratio of the Value added (% of GDP) of Portugal in 2009 to that in 2012?
Ensure brevity in your answer.  1.03. What is the ratio of the Value added (% of GDP) of Latin America(developing only) in 2010 to that in 2011?
Offer a terse response. 0.98. What is the ratio of the Value added (% of GDP) in Finland in 2010 to that in 2011?
Provide a succinct answer. 1.04. What is the ratio of the Value added (% of GDP) in Mauritania in 2010 to that in 2011?
Offer a very short reply. 0.87. What is the ratio of the Value added (% of GDP) in Portugal in 2010 to that in 2011?
Your answer should be very brief. 1.02. What is the ratio of the Value added (% of GDP) of Finland in 2010 to that in 2012?
Your answer should be compact. 1.11. What is the ratio of the Value added (% of GDP) of Portugal in 2010 to that in 2012?
Keep it short and to the point. 1.04. What is the ratio of the Value added (% of GDP) in Latin America(developing only) in 2011 to that in 2012?
Offer a very short reply. 1.01. What is the ratio of the Value added (% of GDP) in Finland in 2011 to that in 2012?
Make the answer very short. 1.07. What is the ratio of the Value added (% of GDP) in Mauritania in 2011 to that in 2012?
Provide a succinct answer. 1.09. What is the ratio of the Value added (% of GDP) of Portugal in 2011 to that in 2012?
Offer a terse response. 1.01. What is the difference between the highest and the second highest Value added (% of GDP) of Latin America(developing only)?
Make the answer very short. 0.14. What is the difference between the highest and the second highest Value added (% of GDP) of Finland?
Offer a very short reply. 0.31. What is the difference between the highest and the second highest Value added (% of GDP) of Mauritania?
Provide a short and direct response. 0.99. What is the difference between the highest and the second highest Value added (% of GDP) of Portugal?
Offer a very short reply. 0.1. What is the difference between the highest and the lowest Value added (% of GDP) of Latin America(developing only)?
Provide a succinct answer. 1.88. What is the difference between the highest and the lowest Value added (% of GDP) of Finland?
Offer a terse response. 8.01. What is the difference between the highest and the lowest Value added (% of GDP) of Mauritania?
Your response must be concise. 12.05. What is the difference between the highest and the lowest Value added (% of GDP) in Portugal?
Your answer should be very brief. 2.66. 